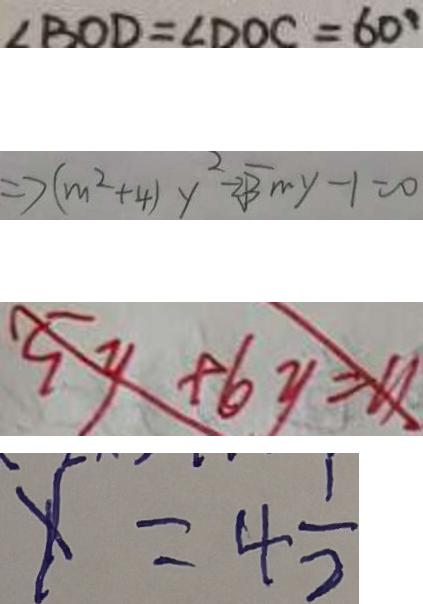<formula> <loc_0><loc_0><loc_500><loc_500>\angle B O D = \angle D O C = 6 0 ^ { \circ } 
 \Rightarrow ( m ^ { 2 } + 4 ) y ^ { 2 } - 2 \sqrt { 3 } m y - 1 = 0 
 5 y + 6 y = 1 1 
 x = 4 \frac { 1 } { 2 }</formula> 